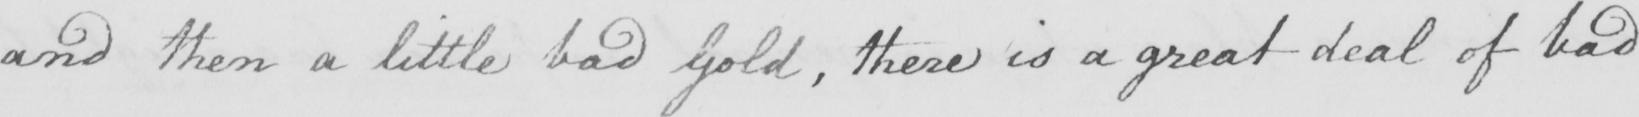Transcribe the text shown in this historical manuscript line. and then a little bad Gold , there is a great deal of bad 